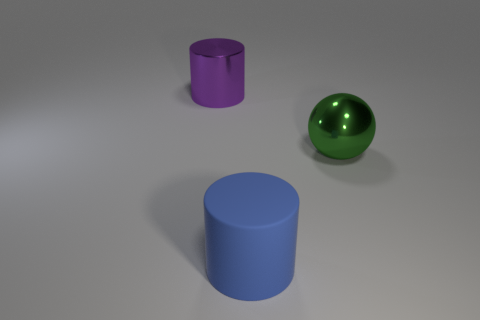Subtract 1 cylinders. How many cylinders are left? 1 Add 1 yellow rubber things. How many objects exist? 4 Subtract all cylinders. How many objects are left? 1 Subtract all green cubes. How many blue cylinders are left? 1 Subtract all brown metallic cylinders. Subtract all big matte things. How many objects are left? 2 Add 2 rubber cylinders. How many rubber cylinders are left? 3 Add 2 large purple shiny things. How many large purple shiny things exist? 3 Subtract all purple cylinders. How many cylinders are left? 1 Subtract 0 brown cylinders. How many objects are left? 3 Subtract all red spheres. Subtract all red blocks. How many spheres are left? 1 